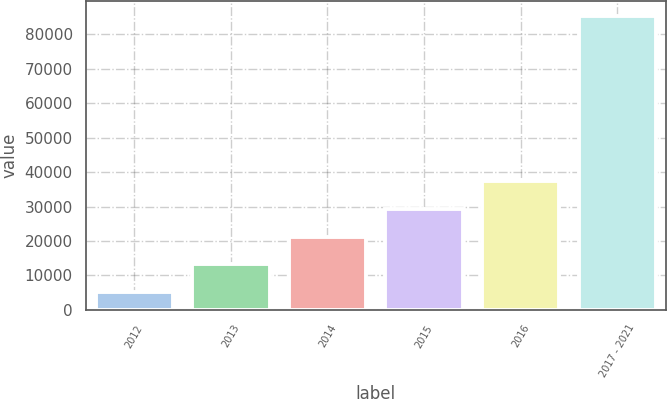Convert chart. <chart><loc_0><loc_0><loc_500><loc_500><bar_chart><fcel>2012<fcel>2013<fcel>2014<fcel>2015<fcel>2016<fcel>2017 - 2021<nl><fcel>5232<fcel>13244.5<fcel>21257<fcel>29269.5<fcel>37282<fcel>85357<nl></chart> 